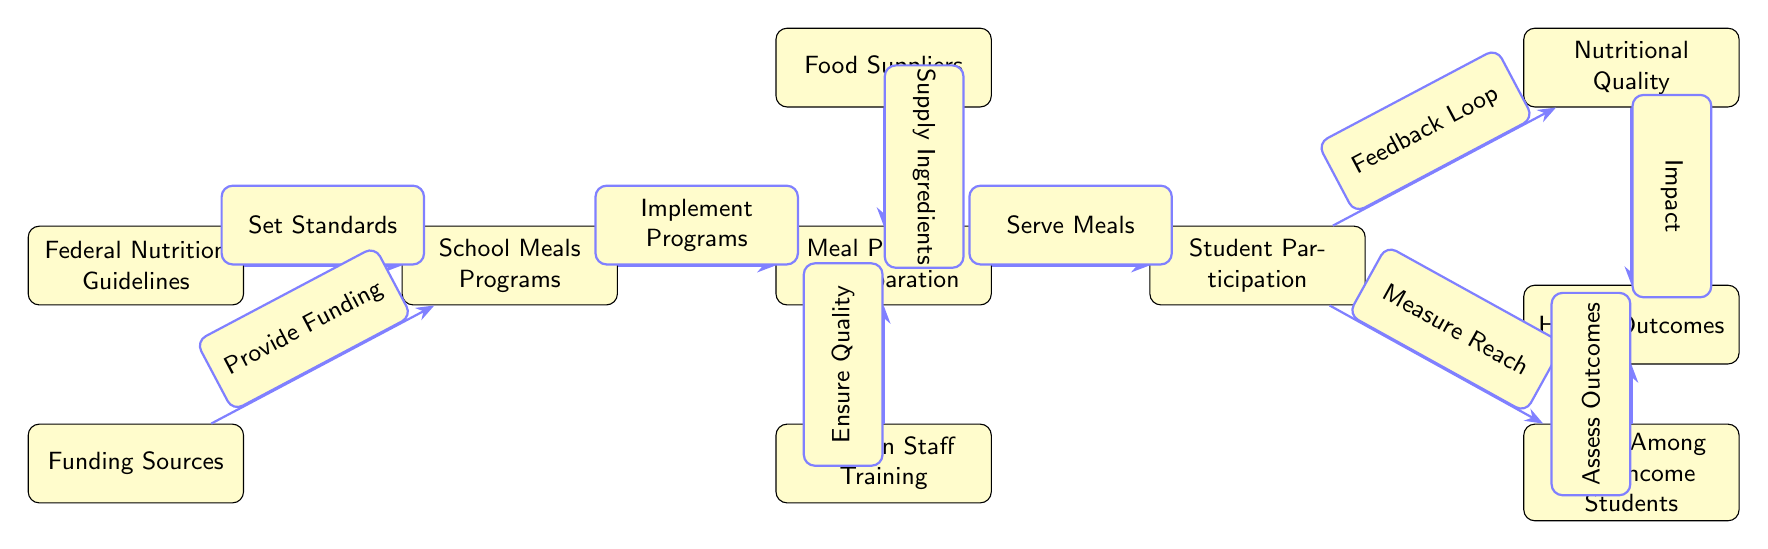What is the first node in the diagram? The first node listed is "Federal Nutrition Guidelines." This node is at the top of the diagram and is where the flow of actions begins.
Answer: Federal Nutrition Guidelines How many nodes are present in the diagram? By counting the nodes listed, there are a total of seven nodes included in the diagram.
Answer: Seven What does the "Funding Sources" node provide? The edge connecting "Funding Sources" to "School Meals Programs" indicates that it provides funding, which is necessary for implementing those programs.
Answer: Provide Funding What is the relationship between "Student Participation" and "Nutritional Quality"? The diagram shows a flow from "Student Participation" to "Nutritional Quality," labeled as "Feedback Loop," indicating that the quality of nutrition is influenced by student participation.
Answer: Feedback Loop What does "Low-Income Reach" measure? In the diagram, "Low-Income Reach" is directly connected to "Student Participation" and is said to measure reach, indicating it assesses the number of low-income students benefiting from the program.
Answer: Measure Reach What is the final node, and what does it represent? The final node in the flow is "Health Outcomes," which is the result of various factors including nutritional quality and reach among low-income students.
Answer: Health Outcomes Explain how "Meal Planning & Preparation" is connected to "Kitchen Staff Training." The edge from "Kitchen Staff Training" to "Meal Planning & Preparation" indicates that training is essential to ensure the quality of meals being prepared. This connection highlights the importance of having well-trained kitchen staff for effective meal planning.
Answer: Ensure Quality How does "Nutritional Quality" impact the process? "Nutritional Quality" is impacted by student participation and subsequently impacts "Health Outcomes," showing that effective feedback from participation can enhance the nutritional quality that ultimately affects health.
Answer: Impact What role does "Food Suppliers" play in the diagram? "Food Suppliers" supply ingredients to "Meal Planning & Preparation," which is essential for the program's operations, indicating their important role in providing necessary foods for school meals.
Answer: Supply Ingredients 